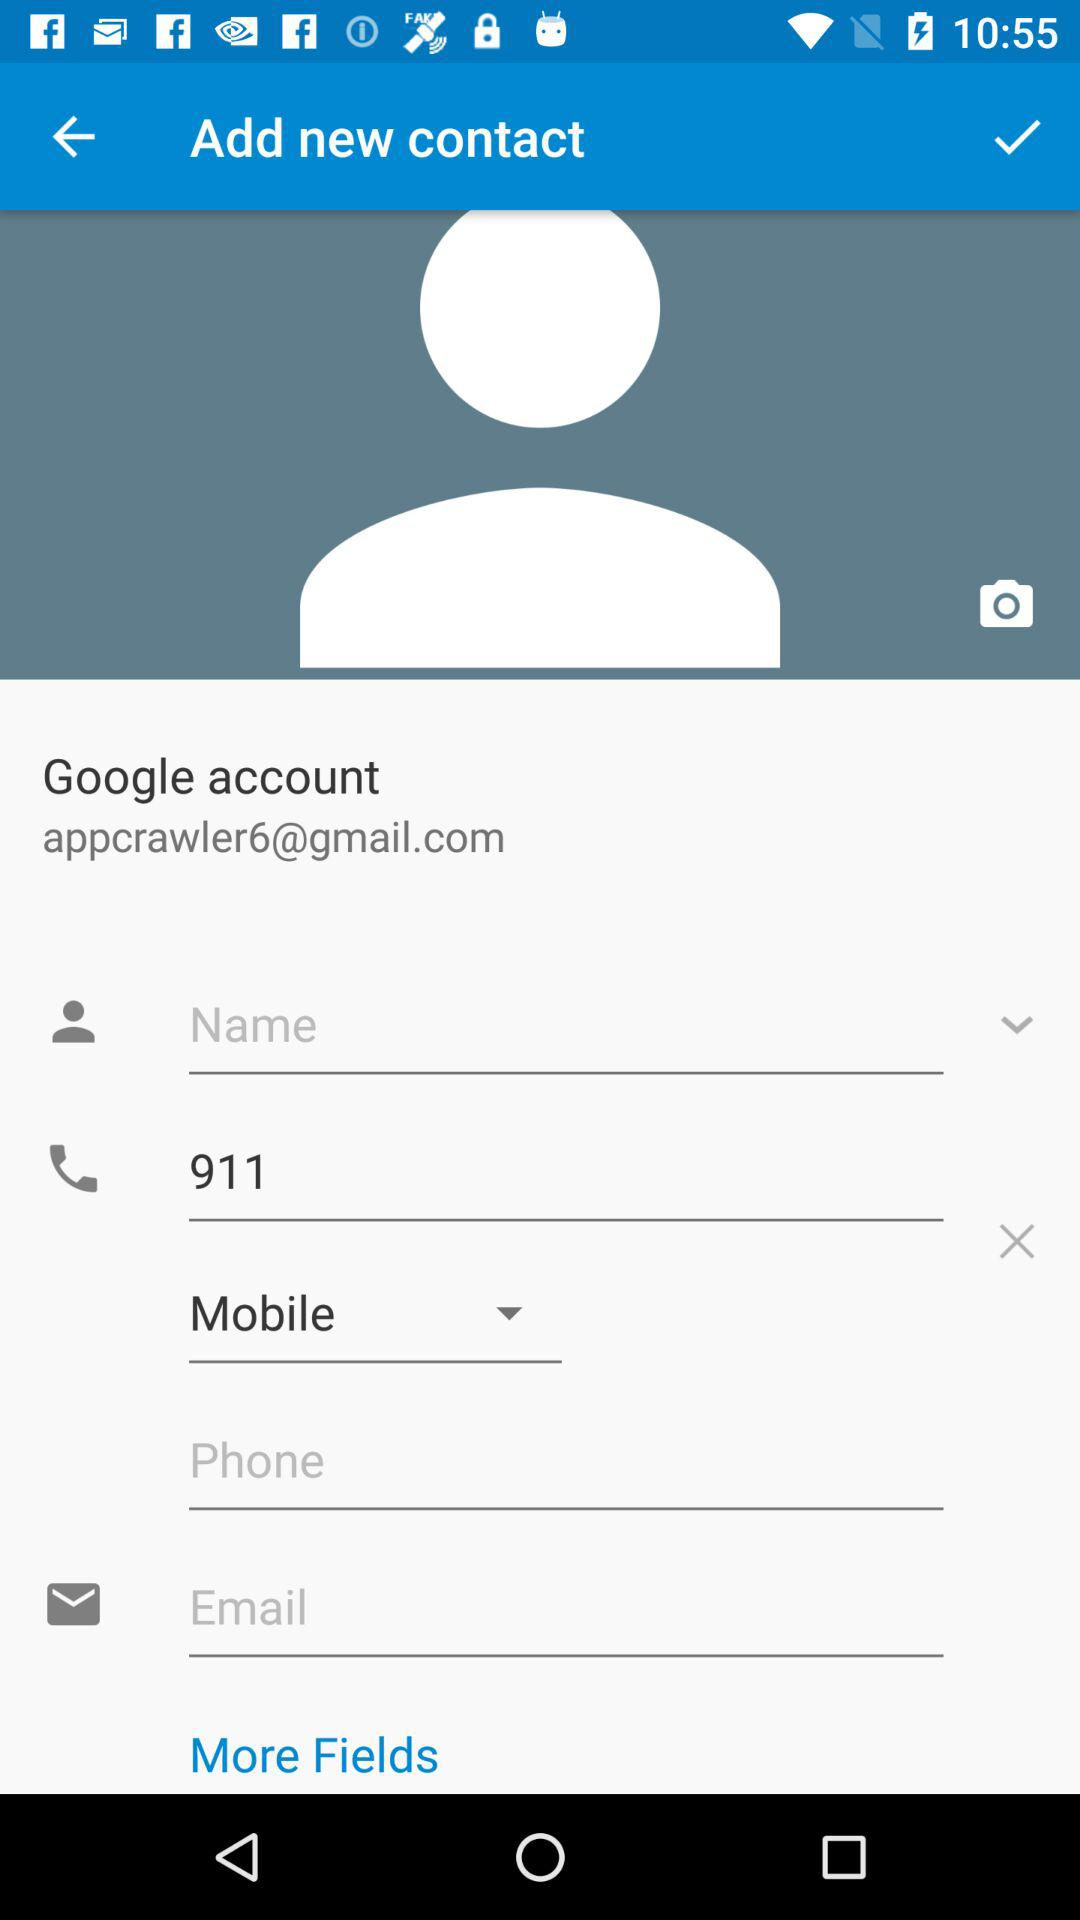What is the selected device type? The selected device is "Mobile". 